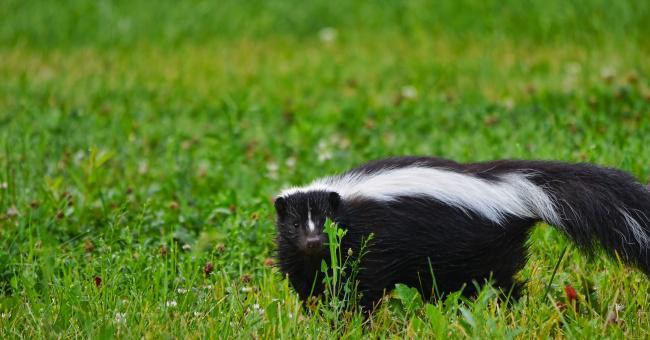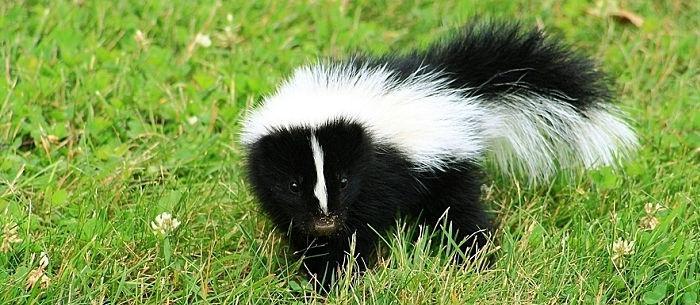The first image is the image on the left, the second image is the image on the right. Considering the images on both sides, is "Two skunks are on a piece of wood in one of the images." valid? Answer yes or no. No. The first image is the image on the left, the second image is the image on the right. For the images shown, is this caption "The right image shows at least two skunks by the hollow of a fallen log." true? Answer yes or no. No. 